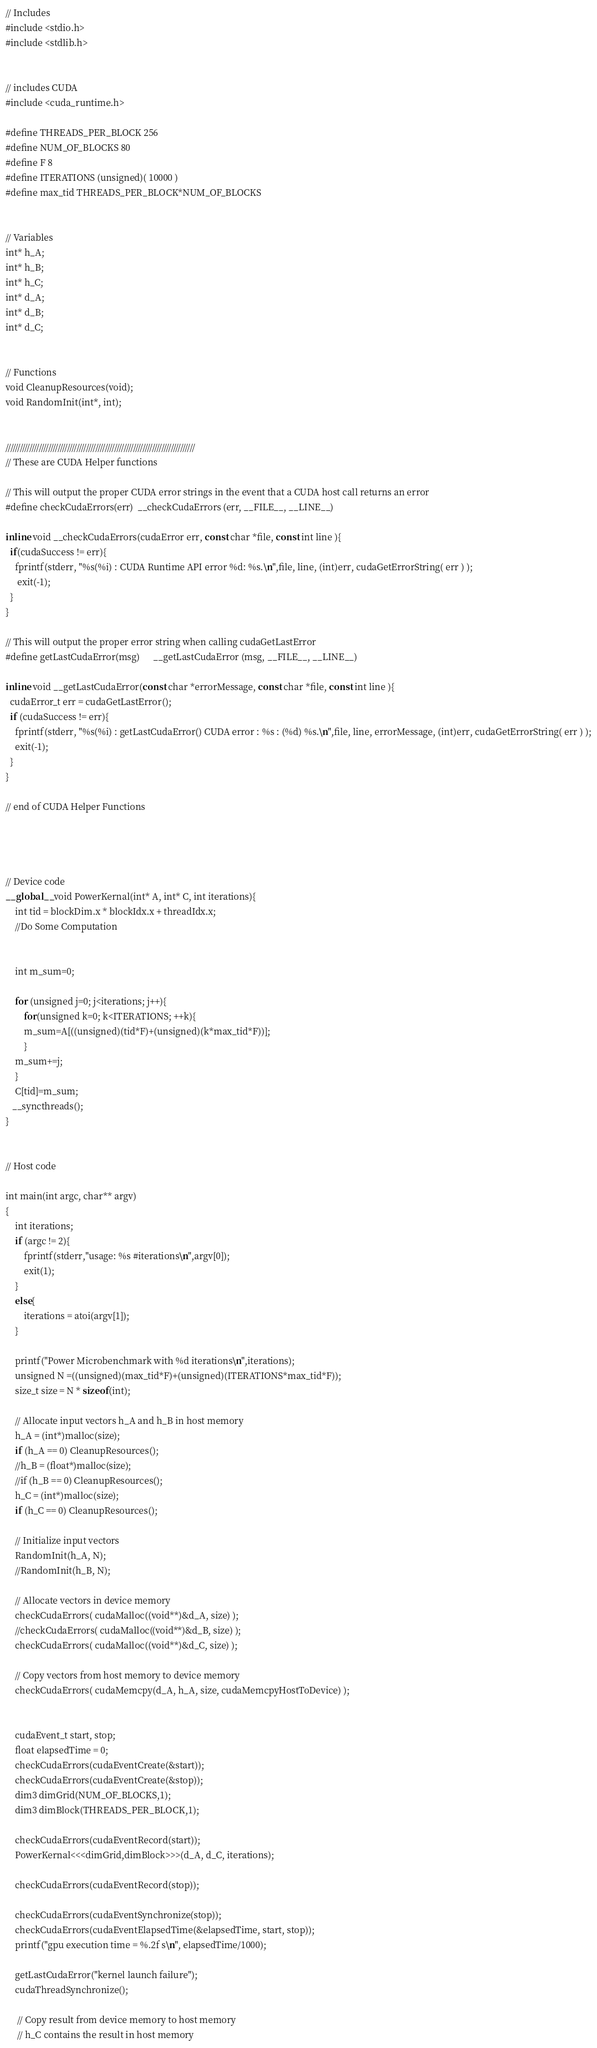Convert code to text. <code><loc_0><loc_0><loc_500><loc_500><_Cuda_>// Includes
#include <stdio.h>
#include <stdlib.h>


// includes CUDA
#include <cuda_runtime.h>

#define THREADS_PER_BLOCK 256
#define NUM_OF_BLOCKS 80
#define F 8
#define ITERATIONS (unsigned)( 10000 )
#define max_tid THREADS_PER_BLOCK*NUM_OF_BLOCKS


// Variables
int* h_A;
int* h_B;
int* h_C;
int* d_A;
int* d_B;
int* d_C;


// Functions
void CleanupResources(void);
void RandomInit(int*, int);


////////////////////////////////////////////////////////////////////////////////
// These are CUDA Helper functions

// This will output the proper CUDA error strings in the event that a CUDA host call returns an error
#define checkCudaErrors(err)  __checkCudaErrors (err, __FILE__, __LINE__)

inline void __checkCudaErrors(cudaError err, const char *file, const int line ){
  if(cudaSuccess != err){
	fprintf(stderr, "%s(%i) : CUDA Runtime API error %d: %s.\n",file, line, (int)err, cudaGetErrorString( err ) );
	 exit(-1);
  }
}

// This will output the proper error string when calling cudaGetLastError
#define getLastCudaError(msg)      __getLastCudaError (msg, __FILE__, __LINE__)

inline void __getLastCudaError(const char *errorMessage, const char *file, const int line ){
  cudaError_t err = cudaGetLastError();
  if (cudaSuccess != err){
	fprintf(stderr, "%s(%i) : getLastCudaError() CUDA error : %s : (%d) %s.\n",file, line, errorMessage, (int)err, cudaGetErrorString( err ) );
	exit(-1);
  }
}

// end of CUDA Helper Functions




// Device code
__global__ void PowerKernal(int* A, int* C, int iterations){
    int tid = blockDim.x * blockIdx.x + threadIdx.x;
    //Do Some Computation


    int m_sum=0;

    for (unsigned j=0; j<iterations; j++){
    	for(unsigned k=0; k<ITERATIONS; ++k){
		m_sum=A[((unsigned)(tid*F)+(unsigned)(k*max_tid*F))];
    	}
	m_sum+=j;
    }
    C[tid]=m_sum;
   __syncthreads();
}


// Host code

int main(int argc, char** argv) 
{
	int iterations;
	if (argc != 2){
		fprintf(stderr,"usage: %s #iterations\n",argv[0]);
		exit(1);
	}
	else{
		iterations = atoi(argv[1]);
	}

	printf("Power Microbenchmark with %d iterations\n",iterations);
	unsigned N =((unsigned)(max_tid*F)+(unsigned)(ITERATIONS*max_tid*F));
	size_t size = N * sizeof(int);

	// Allocate input vectors h_A and h_B in host memory
	h_A = (int*)malloc(size);
	if (h_A == 0) CleanupResources();
	//h_B = (float*)malloc(size);
	//if (h_B == 0) CleanupResources();
	h_C = (int*)malloc(size);
	if (h_C == 0) CleanupResources();

	// Initialize input vectors
	RandomInit(h_A, N);
	//RandomInit(h_B, N);

	// Allocate vectors in device memory
	checkCudaErrors( cudaMalloc((void**)&d_A, size) );
	//checkCudaErrors( cudaMalloc((void**)&d_B, size) );
	checkCudaErrors( cudaMalloc((void**)&d_C, size) );

	// Copy vectors from host memory to device memory
	checkCudaErrors( cudaMemcpy(d_A, h_A, size, cudaMemcpyHostToDevice) );


	cudaEvent_t start, stop;
	float elapsedTime = 0;
	checkCudaErrors(cudaEventCreate(&start));
	checkCudaErrors(cudaEventCreate(&stop));
	dim3 dimGrid(NUM_OF_BLOCKS,1);
	dim3 dimBlock(THREADS_PER_BLOCK,1);

	checkCudaErrors(cudaEventRecord(start));
	PowerKernal<<<dimGrid,dimBlock>>>(d_A, d_C, iterations);

	checkCudaErrors(cudaEventRecord(stop));

	checkCudaErrors(cudaEventSynchronize(stop));
	checkCudaErrors(cudaEventElapsedTime(&elapsedTime, start, stop));
	printf("gpu execution time = %.2f s\n", elapsedTime/1000);

	getLastCudaError("kernel launch failure");
	cudaThreadSynchronize();

	 // Copy result from device memory to host memory
	 // h_C contains the result in host memory</code> 